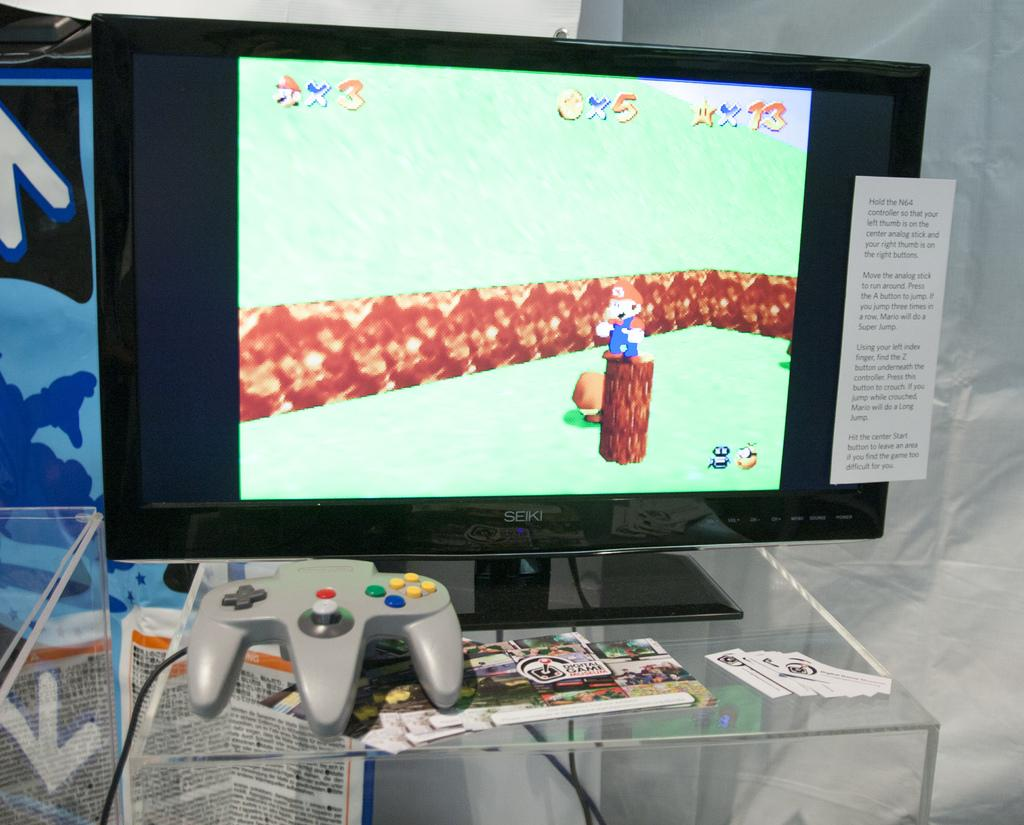<image>
Give a short and clear explanation of the subsequent image. a screen that has the number 3 at the top 